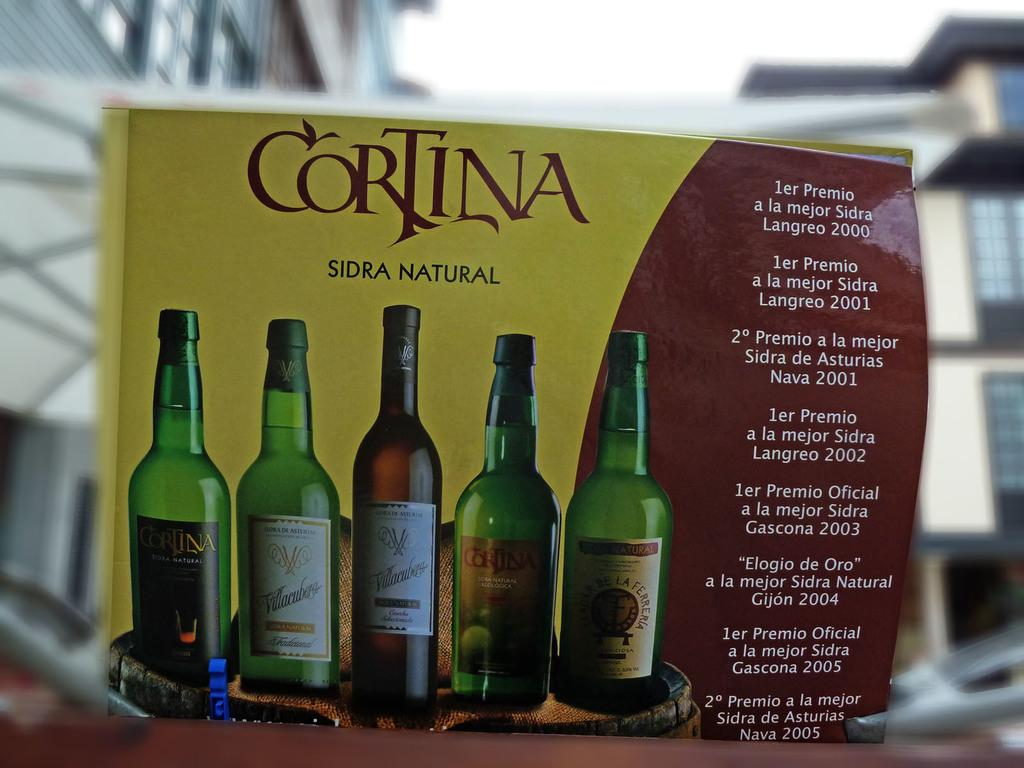<image>
Relay a brief, clear account of the picture shown. The Cortina cider has won many awards from 2000 to 2005. 